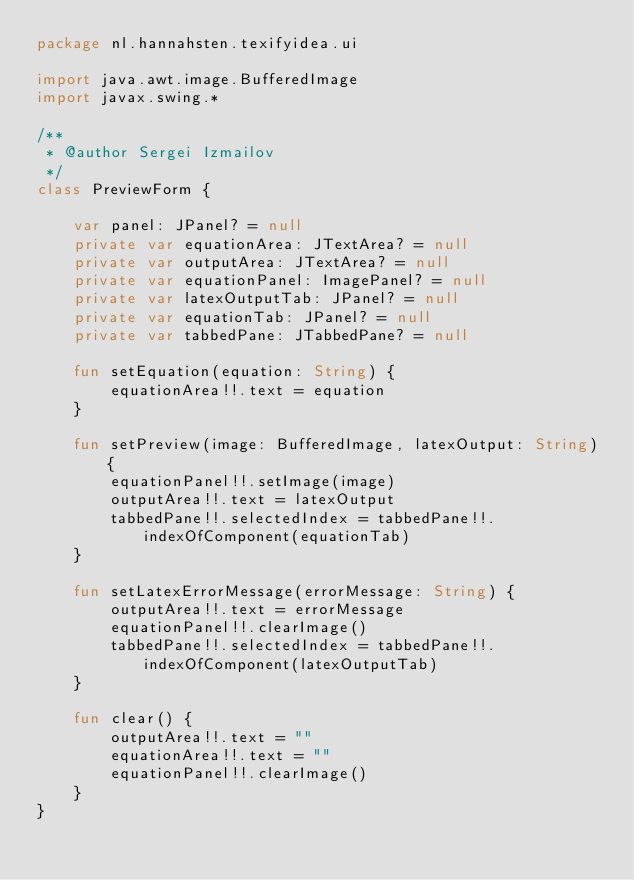<code> <loc_0><loc_0><loc_500><loc_500><_Kotlin_>package nl.hannahsten.texifyidea.ui

import java.awt.image.BufferedImage
import javax.swing.*

/**
 * @author Sergei Izmailov
 */
class PreviewForm {

    var panel: JPanel? = null
    private var equationArea: JTextArea? = null
    private var outputArea: JTextArea? = null
    private var equationPanel: ImagePanel? = null
    private var latexOutputTab: JPanel? = null
    private var equationTab: JPanel? = null
    private var tabbedPane: JTabbedPane? = null

    fun setEquation(equation: String) {
        equationArea!!.text = equation
    }

    fun setPreview(image: BufferedImage, latexOutput: String) {
        equationPanel!!.setImage(image)
        outputArea!!.text = latexOutput
        tabbedPane!!.selectedIndex = tabbedPane!!.indexOfComponent(equationTab)
    }

    fun setLatexErrorMessage(errorMessage: String) {
        outputArea!!.text = errorMessage
        equationPanel!!.clearImage()
        tabbedPane!!.selectedIndex = tabbedPane!!.indexOfComponent(latexOutputTab)
    }

    fun clear() {
        outputArea!!.text = ""
        equationArea!!.text = ""
        equationPanel!!.clearImage()
    }
}
</code> 